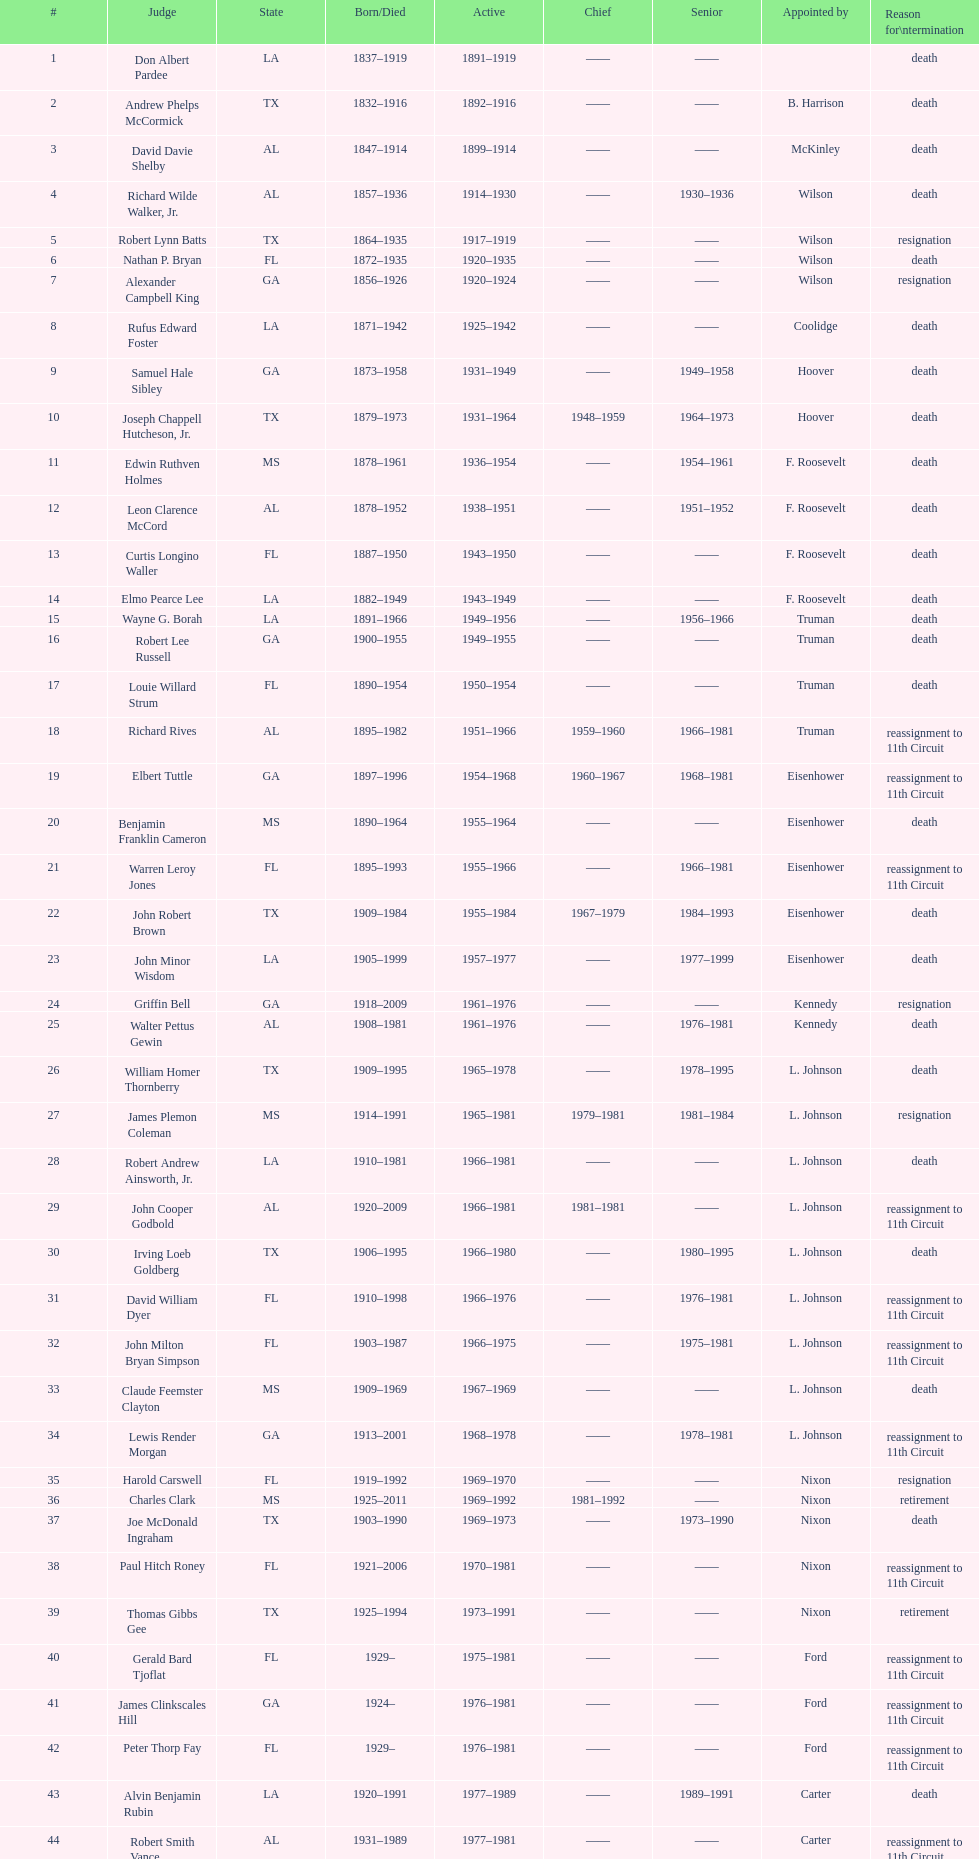Who was the first judge from florida to serve the position? Nathan P. Bryan. 